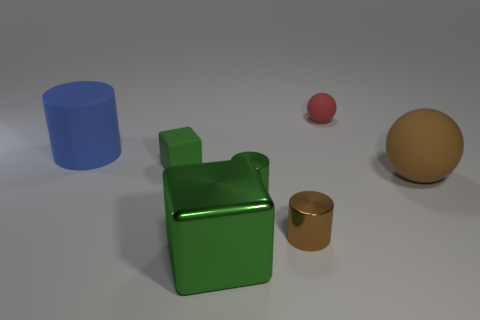There is a small rubber object that is in front of the large blue matte cylinder; does it have the same color as the big cube? No, the small rubber object in front of the large blue matte cylinder is red, while the large cube is green. Despite being different in color, both objects add a vibrant contrast to the scene. 